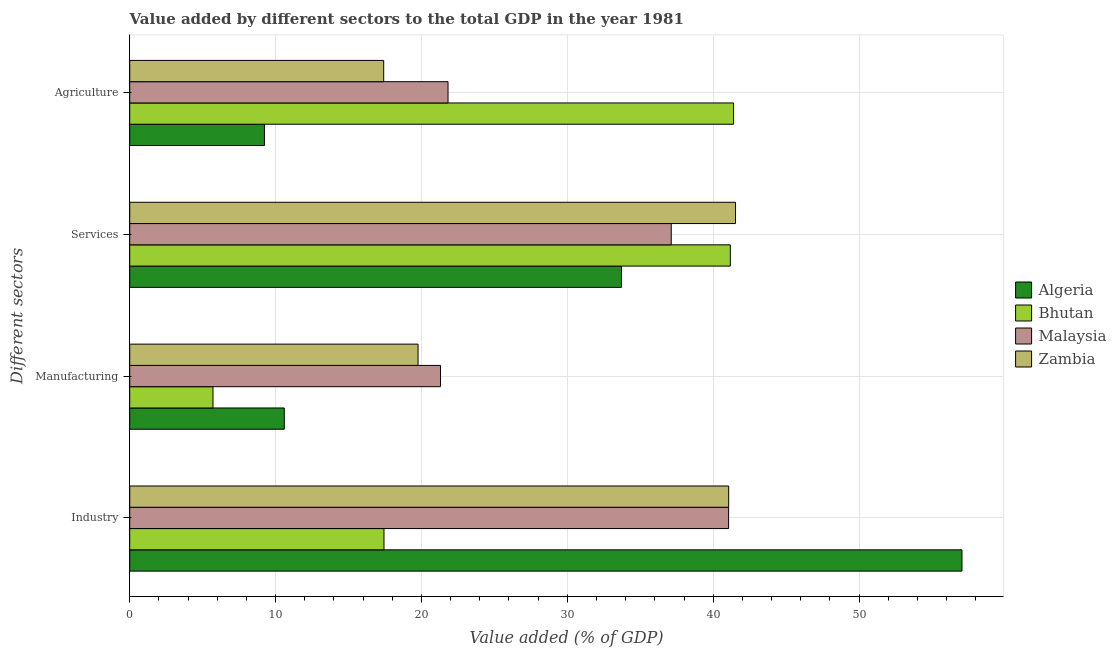How many different coloured bars are there?
Offer a terse response. 4. Are the number of bars per tick equal to the number of legend labels?
Offer a very short reply. Yes. Are the number of bars on each tick of the Y-axis equal?
Offer a very short reply. Yes. How many bars are there on the 1st tick from the top?
Your answer should be very brief. 4. How many bars are there on the 4th tick from the bottom?
Make the answer very short. 4. What is the label of the 4th group of bars from the top?
Offer a terse response. Industry. What is the value added by manufacturing sector in Algeria?
Provide a succinct answer. 10.59. Across all countries, what is the maximum value added by services sector?
Ensure brevity in your answer.  41.53. Across all countries, what is the minimum value added by manufacturing sector?
Provide a succinct answer. 5.71. In which country was the value added by agricultural sector maximum?
Provide a succinct answer. Bhutan. In which country was the value added by agricultural sector minimum?
Offer a terse response. Algeria. What is the total value added by agricultural sector in the graph?
Provide a succinct answer. 89.86. What is the difference between the value added by services sector in Algeria and that in Malaysia?
Offer a very short reply. -3.41. What is the difference between the value added by manufacturing sector in Bhutan and the value added by agricultural sector in Malaysia?
Make the answer very short. -16.11. What is the average value added by manufacturing sector per country?
Offer a very short reply. 14.34. What is the difference between the value added by manufacturing sector and value added by industrial sector in Algeria?
Make the answer very short. -46.46. In how many countries, is the value added by services sector greater than 44 %?
Your answer should be compact. 0. What is the ratio of the value added by agricultural sector in Bhutan to that in Malaysia?
Provide a short and direct response. 1.9. Is the value added by manufacturing sector in Zambia less than that in Bhutan?
Make the answer very short. No. Is the difference between the value added by agricultural sector in Algeria and Malaysia greater than the difference between the value added by manufacturing sector in Algeria and Malaysia?
Ensure brevity in your answer.  No. What is the difference between the highest and the second highest value added by agricultural sector?
Provide a succinct answer. 19.57. What is the difference between the highest and the lowest value added by agricultural sector?
Your response must be concise. 32.16. In how many countries, is the value added by agricultural sector greater than the average value added by agricultural sector taken over all countries?
Give a very brief answer. 1. What does the 3rd bar from the top in Services represents?
Provide a succinct answer. Bhutan. What does the 1st bar from the bottom in Services represents?
Your answer should be compact. Algeria. How many countries are there in the graph?
Ensure brevity in your answer.  4. Are the values on the major ticks of X-axis written in scientific E-notation?
Provide a short and direct response. No. Does the graph contain any zero values?
Offer a terse response. No. Does the graph contain grids?
Your answer should be very brief. Yes. How many legend labels are there?
Provide a succinct answer. 4. What is the title of the graph?
Make the answer very short. Value added by different sectors to the total GDP in the year 1981. Does "Equatorial Guinea" appear as one of the legend labels in the graph?
Your response must be concise. No. What is the label or title of the X-axis?
Offer a very short reply. Value added (% of GDP). What is the label or title of the Y-axis?
Your response must be concise. Different sectors. What is the Value added (% of GDP) in Algeria in Industry?
Provide a succinct answer. 57.05. What is the Value added (% of GDP) in Bhutan in Industry?
Make the answer very short. 17.43. What is the Value added (% of GDP) of Malaysia in Industry?
Make the answer very short. 41.06. What is the Value added (% of GDP) of Zambia in Industry?
Ensure brevity in your answer.  41.06. What is the Value added (% of GDP) of Algeria in Manufacturing?
Keep it short and to the point. 10.59. What is the Value added (% of GDP) in Bhutan in Manufacturing?
Provide a succinct answer. 5.71. What is the Value added (% of GDP) in Malaysia in Manufacturing?
Provide a short and direct response. 21.3. What is the Value added (% of GDP) in Zambia in Manufacturing?
Your answer should be very brief. 19.77. What is the Value added (% of GDP) in Algeria in Services?
Your response must be concise. 33.71. What is the Value added (% of GDP) in Bhutan in Services?
Your answer should be compact. 41.17. What is the Value added (% of GDP) of Malaysia in Services?
Make the answer very short. 37.12. What is the Value added (% of GDP) of Zambia in Services?
Your answer should be very brief. 41.53. What is the Value added (% of GDP) of Algeria in Agriculture?
Your response must be concise. 9.24. What is the Value added (% of GDP) in Bhutan in Agriculture?
Your answer should be compact. 41.4. What is the Value added (% of GDP) of Malaysia in Agriculture?
Give a very brief answer. 21.82. What is the Value added (% of GDP) in Zambia in Agriculture?
Keep it short and to the point. 17.41. Across all Different sectors, what is the maximum Value added (% of GDP) of Algeria?
Your response must be concise. 57.05. Across all Different sectors, what is the maximum Value added (% of GDP) in Bhutan?
Ensure brevity in your answer.  41.4. Across all Different sectors, what is the maximum Value added (% of GDP) of Malaysia?
Provide a short and direct response. 41.06. Across all Different sectors, what is the maximum Value added (% of GDP) in Zambia?
Your answer should be compact. 41.53. Across all Different sectors, what is the minimum Value added (% of GDP) of Algeria?
Your answer should be very brief. 9.24. Across all Different sectors, what is the minimum Value added (% of GDP) in Bhutan?
Your answer should be very brief. 5.71. Across all Different sectors, what is the minimum Value added (% of GDP) in Malaysia?
Provide a succinct answer. 21.3. Across all Different sectors, what is the minimum Value added (% of GDP) in Zambia?
Offer a very short reply. 17.41. What is the total Value added (% of GDP) in Algeria in the graph?
Give a very brief answer. 110.59. What is the total Value added (% of GDP) in Bhutan in the graph?
Provide a succinct answer. 105.71. What is the total Value added (% of GDP) of Malaysia in the graph?
Give a very brief answer. 121.3. What is the total Value added (% of GDP) in Zambia in the graph?
Your response must be concise. 119.77. What is the difference between the Value added (% of GDP) in Algeria in Industry and that in Manufacturing?
Your answer should be very brief. 46.46. What is the difference between the Value added (% of GDP) in Bhutan in Industry and that in Manufacturing?
Give a very brief answer. 11.72. What is the difference between the Value added (% of GDP) in Malaysia in Industry and that in Manufacturing?
Make the answer very short. 19.75. What is the difference between the Value added (% of GDP) in Zambia in Industry and that in Manufacturing?
Give a very brief answer. 21.29. What is the difference between the Value added (% of GDP) in Algeria in Industry and that in Services?
Ensure brevity in your answer.  23.34. What is the difference between the Value added (% of GDP) of Bhutan in Industry and that in Services?
Ensure brevity in your answer.  -23.74. What is the difference between the Value added (% of GDP) of Malaysia in Industry and that in Services?
Your response must be concise. 3.93. What is the difference between the Value added (% of GDP) of Zambia in Industry and that in Services?
Ensure brevity in your answer.  -0.47. What is the difference between the Value added (% of GDP) of Algeria in Industry and that in Agriculture?
Offer a terse response. 47.82. What is the difference between the Value added (% of GDP) in Bhutan in Industry and that in Agriculture?
Offer a terse response. -23.97. What is the difference between the Value added (% of GDP) of Malaysia in Industry and that in Agriculture?
Your answer should be very brief. 19.24. What is the difference between the Value added (% of GDP) in Zambia in Industry and that in Agriculture?
Ensure brevity in your answer.  23.65. What is the difference between the Value added (% of GDP) of Algeria in Manufacturing and that in Services?
Give a very brief answer. -23.12. What is the difference between the Value added (% of GDP) in Bhutan in Manufacturing and that in Services?
Ensure brevity in your answer.  -35.47. What is the difference between the Value added (% of GDP) in Malaysia in Manufacturing and that in Services?
Offer a very short reply. -15.82. What is the difference between the Value added (% of GDP) in Zambia in Manufacturing and that in Services?
Provide a succinct answer. -21.76. What is the difference between the Value added (% of GDP) in Algeria in Manufacturing and that in Agriculture?
Make the answer very short. 1.36. What is the difference between the Value added (% of GDP) of Bhutan in Manufacturing and that in Agriculture?
Your response must be concise. -35.69. What is the difference between the Value added (% of GDP) of Malaysia in Manufacturing and that in Agriculture?
Provide a succinct answer. -0.52. What is the difference between the Value added (% of GDP) in Zambia in Manufacturing and that in Agriculture?
Keep it short and to the point. 2.36. What is the difference between the Value added (% of GDP) of Algeria in Services and that in Agriculture?
Your answer should be very brief. 24.48. What is the difference between the Value added (% of GDP) in Bhutan in Services and that in Agriculture?
Your response must be concise. -0.22. What is the difference between the Value added (% of GDP) of Malaysia in Services and that in Agriculture?
Ensure brevity in your answer.  15.3. What is the difference between the Value added (% of GDP) in Zambia in Services and that in Agriculture?
Your answer should be compact. 24.12. What is the difference between the Value added (% of GDP) in Algeria in Industry and the Value added (% of GDP) in Bhutan in Manufacturing?
Your answer should be very brief. 51.35. What is the difference between the Value added (% of GDP) in Algeria in Industry and the Value added (% of GDP) in Malaysia in Manufacturing?
Give a very brief answer. 35.75. What is the difference between the Value added (% of GDP) of Algeria in Industry and the Value added (% of GDP) of Zambia in Manufacturing?
Offer a terse response. 37.29. What is the difference between the Value added (% of GDP) of Bhutan in Industry and the Value added (% of GDP) of Malaysia in Manufacturing?
Offer a terse response. -3.87. What is the difference between the Value added (% of GDP) in Bhutan in Industry and the Value added (% of GDP) in Zambia in Manufacturing?
Your answer should be compact. -2.34. What is the difference between the Value added (% of GDP) in Malaysia in Industry and the Value added (% of GDP) in Zambia in Manufacturing?
Your answer should be compact. 21.29. What is the difference between the Value added (% of GDP) in Algeria in Industry and the Value added (% of GDP) in Bhutan in Services?
Give a very brief answer. 15.88. What is the difference between the Value added (% of GDP) in Algeria in Industry and the Value added (% of GDP) in Malaysia in Services?
Give a very brief answer. 19.93. What is the difference between the Value added (% of GDP) of Algeria in Industry and the Value added (% of GDP) of Zambia in Services?
Your response must be concise. 15.52. What is the difference between the Value added (% of GDP) in Bhutan in Industry and the Value added (% of GDP) in Malaysia in Services?
Give a very brief answer. -19.69. What is the difference between the Value added (% of GDP) in Bhutan in Industry and the Value added (% of GDP) in Zambia in Services?
Provide a succinct answer. -24.1. What is the difference between the Value added (% of GDP) of Malaysia in Industry and the Value added (% of GDP) of Zambia in Services?
Offer a very short reply. -0.47. What is the difference between the Value added (% of GDP) in Algeria in Industry and the Value added (% of GDP) in Bhutan in Agriculture?
Offer a terse response. 15.66. What is the difference between the Value added (% of GDP) in Algeria in Industry and the Value added (% of GDP) in Malaysia in Agriculture?
Give a very brief answer. 35.23. What is the difference between the Value added (% of GDP) of Algeria in Industry and the Value added (% of GDP) of Zambia in Agriculture?
Offer a terse response. 39.64. What is the difference between the Value added (% of GDP) of Bhutan in Industry and the Value added (% of GDP) of Malaysia in Agriculture?
Offer a terse response. -4.39. What is the difference between the Value added (% of GDP) in Bhutan in Industry and the Value added (% of GDP) in Zambia in Agriculture?
Ensure brevity in your answer.  0.02. What is the difference between the Value added (% of GDP) of Malaysia in Industry and the Value added (% of GDP) of Zambia in Agriculture?
Give a very brief answer. 23.65. What is the difference between the Value added (% of GDP) of Algeria in Manufacturing and the Value added (% of GDP) of Bhutan in Services?
Your answer should be compact. -30.58. What is the difference between the Value added (% of GDP) of Algeria in Manufacturing and the Value added (% of GDP) of Malaysia in Services?
Ensure brevity in your answer.  -26.53. What is the difference between the Value added (% of GDP) of Algeria in Manufacturing and the Value added (% of GDP) of Zambia in Services?
Ensure brevity in your answer.  -30.94. What is the difference between the Value added (% of GDP) in Bhutan in Manufacturing and the Value added (% of GDP) in Malaysia in Services?
Offer a very short reply. -31.41. What is the difference between the Value added (% of GDP) in Bhutan in Manufacturing and the Value added (% of GDP) in Zambia in Services?
Provide a short and direct response. -35.82. What is the difference between the Value added (% of GDP) of Malaysia in Manufacturing and the Value added (% of GDP) of Zambia in Services?
Provide a succinct answer. -20.23. What is the difference between the Value added (% of GDP) of Algeria in Manufacturing and the Value added (% of GDP) of Bhutan in Agriculture?
Offer a very short reply. -30.8. What is the difference between the Value added (% of GDP) in Algeria in Manufacturing and the Value added (% of GDP) in Malaysia in Agriculture?
Give a very brief answer. -11.23. What is the difference between the Value added (% of GDP) in Algeria in Manufacturing and the Value added (% of GDP) in Zambia in Agriculture?
Offer a terse response. -6.82. What is the difference between the Value added (% of GDP) in Bhutan in Manufacturing and the Value added (% of GDP) in Malaysia in Agriculture?
Keep it short and to the point. -16.11. What is the difference between the Value added (% of GDP) in Bhutan in Manufacturing and the Value added (% of GDP) in Zambia in Agriculture?
Your answer should be very brief. -11.7. What is the difference between the Value added (% of GDP) of Malaysia in Manufacturing and the Value added (% of GDP) of Zambia in Agriculture?
Make the answer very short. 3.89. What is the difference between the Value added (% of GDP) of Algeria in Services and the Value added (% of GDP) of Bhutan in Agriculture?
Keep it short and to the point. -7.68. What is the difference between the Value added (% of GDP) of Algeria in Services and the Value added (% of GDP) of Malaysia in Agriculture?
Offer a terse response. 11.89. What is the difference between the Value added (% of GDP) of Algeria in Services and the Value added (% of GDP) of Zambia in Agriculture?
Your answer should be very brief. 16.3. What is the difference between the Value added (% of GDP) of Bhutan in Services and the Value added (% of GDP) of Malaysia in Agriculture?
Keep it short and to the point. 19.35. What is the difference between the Value added (% of GDP) in Bhutan in Services and the Value added (% of GDP) in Zambia in Agriculture?
Your answer should be very brief. 23.76. What is the difference between the Value added (% of GDP) of Malaysia in Services and the Value added (% of GDP) of Zambia in Agriculture?
Offer a terse response. 19.71. What is the average Value added (% of GDP) in Algeria per Different sectors?
Offer a very short reply. 27.65. What is the average Value added (% of GDP) in Bhutan per Different sectors?
Make the answer very short. 26.43. What is the average Value added (% of GDP) in Malaysia per Different sectors?
Provide a succinct answer. 30.33. What is the average Value added (% of GDP) in Zambia per Different sectors?
Offer a very short reply. 29.94. What is the difference between the Value added (% of GDP) in Algeria and Value added (% of GDP) in Bhutan in Industry?
Keep it short and to the point. 39.62. What is the difference between the Value added (% of GDP) in Algeria and Value added (% of GDP) in Malaysia in Industry?
Make the answer very short. 16. What is the difference between the Value added (% of GDP) in Algeria and Value added (% of GDP) in Zambia in Industry?
Offer a terse response. 15.99. What is the difference between the Value added (% of GDP) of Bhutan and Value added (% of GDP) of Malaysia in Industry?
Give a very brief answer. -23.63. What is the difference between the Value added (% of GDP) of Bhutan and Value added (% of GDP) of Zambia in Industry?
Provide a short and direct response. -23.63. What is the difference between the Value added (% of GDP) in Malaysia and Value added (% of GDP) in Zambia in Industry?
Your response must be concise. -0. What is the difference between the Value added (% of GDP) of Algeria and Value added (% of GDP) of Bhutan in Manufacturing?
Your answer should be very brief. 4.89. What is the difference between the Value added (% of GDP) of Algeria and Value added (% of GDP) of Malaysia in Manufacturing?
Make the answer very short. -10.71. What is the difference between the Value added (% of GDP) of Algeria and Value added (% of GDP) of Zambia in Manufacturing?
Your answer should be very brief. -9.17. What is the difference between the Value added (% of GDP) in Bhutan and Value added (% of GDP) in Malaysia in Manufacturing?
Provide a short and direct response. -15.6. What is the difference between the Value added (% of GDP) of Bhutan and Value added (% of GDP) of Zambia in Manufacturing?
Make the answer very short. -14.06. What is the difference between the Value added (% of GDP) in Malaysia and Value added (% of GDP) in Zambia in Manufacturing?
Provide a succinct answer. 1.54. What is the difference between the Value added (% of GDP) of Algeria and Value added (% of GDP) of Bhutan in Services?
Ensure brevity in your answer.  -7.46. What is the difference between the Value added (% of GDP) in Algeria and Value added (% of GDP) in Malaysia in Services?
Provide a short and direct response. -3.41. What is the difference between the Value added (% of GDP) of Algeria and Value added (% of GDP) of Zambia in Services?
Provide a succinct answer. -7.82. What is the difference between the Value added (% of GDP) in Bhutan and Value added (% of GDP) in Malaysia in Services?
Provide a succinct answer. 4.05. What is the difference between the Value added (% of GDP) of Bhutan and Value added (% of GDP) of Zambia in Services?
Keep it short and to the point. -0.36. What is the difference between the Value added (% of GDP) of Malaysia and Value added (% of GDP) of Zambia in Services?
Your answer should be very brief. -4.41. What is the difference between the Value added (% of GDP) of Algeria and Value added (% of GDP) of Bhutan in Agriculture?
Provide a short and direct response. -32.16. What is the difference between the Value added (% of GDP) of Algeria and Value added (% of GDP) of Malaysia in Agriculture?
Give a very brief answer. -12.59. What is the difference between the Value added (% of GDP) of Algeria and Value added (% of GDP) of Zambia in Agriculture?
Ensure brevity in your answer.  -8.17. What is the difference between the Value added (% of GDP) of Bhutan and Value added (% of GDP) of Malaysia in Agriculture?
Provide a short and direct response. 19.57. What is the difference between the Value added (% of GDP) in Bhutan and Value added (% of GDP) in Zambia in Agriculture?
Provide a short and direct response. 23.99. What is the difference between the Value added (% of GDP) in Malaysia and Value added (% of GDP) in Zambia in Agriculture?
Provide a succinct answer. 4.41. What is the ratio of the Value added (% of GDP) in Algeria in Industry to that in Manufacturing?
Offer a terse response. 5.38. What is the ratio of the Value added (% of GDP) of Bhutan in Industry to that in Manufacturing?
Give a very brief answer. 3.05. What is the ratio of the Value added (% of GDP) in Malaysia in Industry to that in Manufacturing?
Offer a terse response. 1.93. What is the ratio of the Value added (% of GDP) in Zambia in Industry to that in Manufacturing?
Offer a very short reply. 2.08. What is the ratio of the Value added (% of GDP) in Algeria in Industry to that in Services?
Ensure brevity in your answer.  1.69. What is the ratio of the Value added (% of GDP) of Bhutan in Industry to that in Services?
Your response must be concise. 0.42. What is the ratio of the Value added (% of GDP) of Malaysia in Industry to that in Services?
Ensure brevity in your answer.  1.11. What is the ratio of the Value added (% of GDP) in Zambia in Industry to that in Services?
Provide a succinct answer. 0.99. What is the ratio of the Value added (% of GDP) in Algeria in Industry to that in Agriculture?
Your response must be concise. 6.18. What is the ratio of the Value added (% of GDP) in Bhutan in Industry to that in Agriculture?
Offer a terse response. 0.42. What is the ratio of the Value added (% of GDP) in Malaysia in Industry to that in Agriculture?
Give a very brief answer. 1.88. What is the ratio of the Value added (% of GDP) in Zambia in Industry to that in Agriculture?
Your response must be concise. 2.36. What is the ratio of the Value added (% of GDP) in Algeria in Manufacturing to that in Services?
Provide a succinct answer. 0.31. What is the ratio of the Value added (% of GDP) of Bhutan in Manufacturing to that in Services?
Ensure brevity in your answer.  0.14. What is the ratio of the Value added (% of GDP) of Malaysia in Manufacturing to that in Services?
Your response must be concise. 0.57. What is the ratio of the Value added (% of GDP) of Zambia in Manufacturing to that in Services?
Ensure brevity in your answer.  0.48. What is the ratio of the Value added (% of GDP) in Algeria in Manufacturing to that in Agriculture?
Give a very brief answer. 1.15. What is the ratio of the Value added (% of GDP) in Bhutan in Manufacturing to that in Agriculture?
Ensure brevity in your answer.  0.14. What is the ratio of the Value added (% of GDP) of Malaysia in Manufacturing to that in Agriculture?
Your response must be concise. 0.98. What is the ratio of the Value added (% of GDP) of Zambia in Manufacturing to that in Agriculture?
Make the answer very short. 1.14. What is the ratio of the Value added (% of GDP) of Algeria in Services to that in Agriculture?
Offer a very short reply. 3.65. What is the ratio of the Value added (% of GDP) in Malaysia in Services to that in Agriculture?
Offer a very short reply. 1.7. What is the ratio of the Value added (% of GDP) of Zambia in Services to that in Agriculture?
Provide a succinct answer. 2.39. What is the difference between the highest and the second highest Value added (% of GDP) in Algeria?
Keep it short and to the point. 23.34. What is the difference between the highest and the second highest Value added (% of GDP) in Bhutan?
Keep it short and to the point. 0.22. What is the difference between the highest and the second highest Value added (% of GDP) in Malaysia?
Ensure brevity in your answer.  3.93. What is the difference between the highest and the second highest Value added (% of GDP) in Zambia?
Your answer should be compact. 0.47. What is the difference between the highest and the lowest Value added (% of GDP) in Algeria?
Provide a short and direct response. 47.82. What is the difference between the highest and the lowest Value added (% of GDP) of Bhutan?
Give a very brief answer. 35.69. What is the difference between the highest and the lowest Value added (% of GDP) of Malaysia?
Your response must be concise. 19.75. What is the difference between the highest and the lowest Value added (% of GDP) of Zambia?
Make the answer very short. 24.12. 